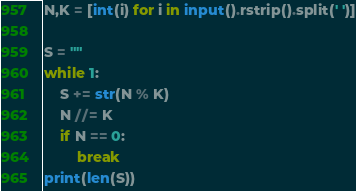<code> <loc_0><loc_0><loc_500><loc_500><_Python_>N,K = [int(i) for i in input().rstrip().split(' ')]

S = ""
while 1:
    S += str(N % K)
    N //= K
    if N == 0:
        break
print(len(S))</code> 